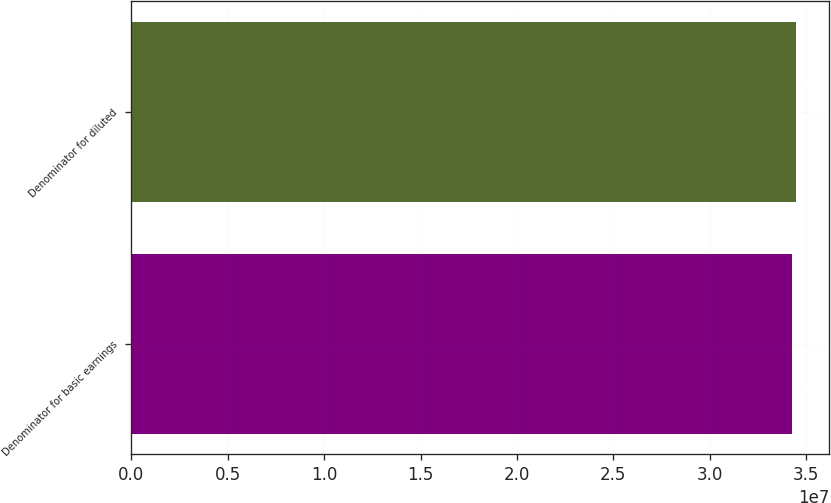Convert chart. <chart><loc_0><loc_0><loc_500><loc_500><bar_chart><fcel>Denominator for basic earnings<fcel>Denominator for diluted<nl><fcel>3.42893e+07<fcel>3.44769e+07<nl></chart> 